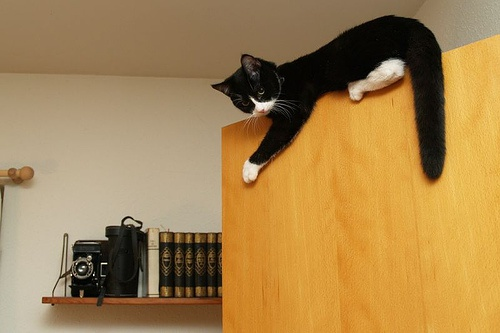Describe the objects in this image and their specific colors. I can see cat in gray, black, maroon, lightgray, and tan tones, book in gray, black, maroon, and olive tones, book in gray, tan, and black tones, book in gray, black, olive, and maroon tones, and book in gray, black, olive, and maroon tones in this image. 